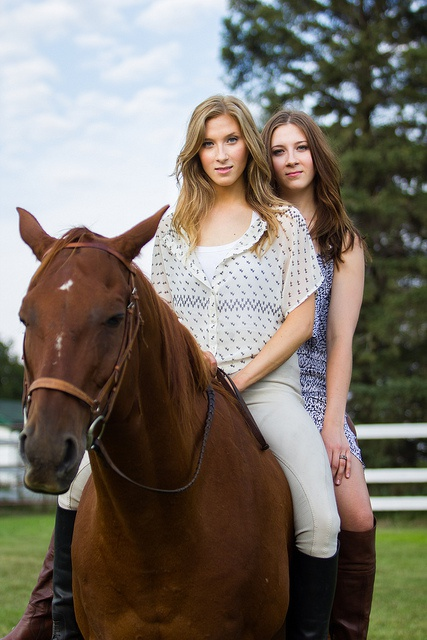Describe the objects in this image and their specific colors. I can see horse in lavender, black, maroon, and gray tones, people in lavender, lightgray, darkgray, black, and tan tones, and people in lavender, black, tan, gray, and maroon tones in this image. 